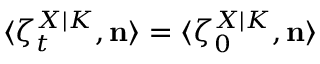<formula> <loc_0><loc_0><loc_500><loc_500>\langle \zeta _ { t } ^ { X | K } , n \rangle = \langle \zeta _ { 0 } ^ { X | K } , n \rangle</formula> 